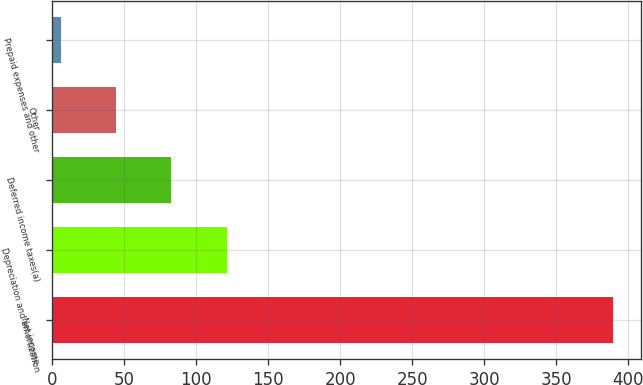<chart> <loc_0><loc_0><loc_500><loc_500><bar_chart><fcel>Net income<fcel>Depreciation and amortization<fcel>Deferred income taxes(a)<fcel>Other<fcel>Prepaid expenses and other<nl><fcel>389.1<fcel>121.14<fcel>82.86<fcel>44.58<fcel>6.3<nl></chart> 